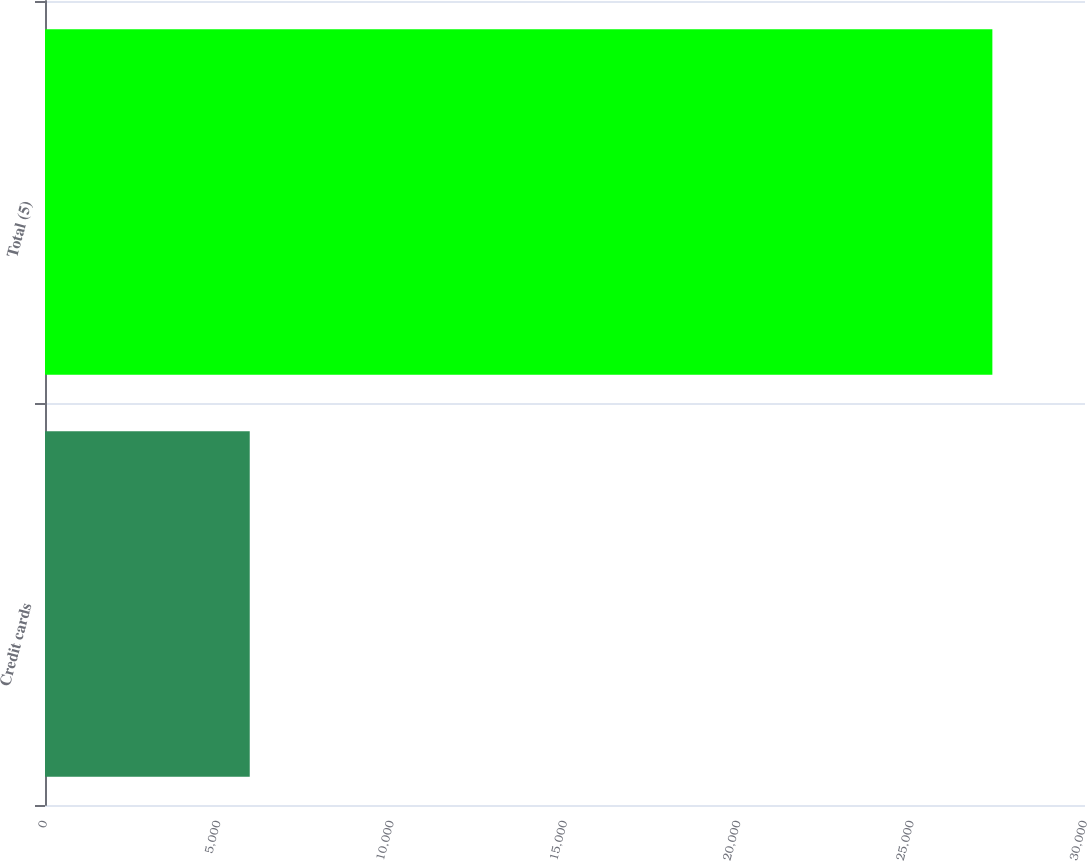Convert chart. <chart><loc_0><loc_0><loc_500><loc_500><bar_chart><fcel>Credit cards<fcel>Total (5)<nl><fcel>5906<fcel>27328<nl></chart> 